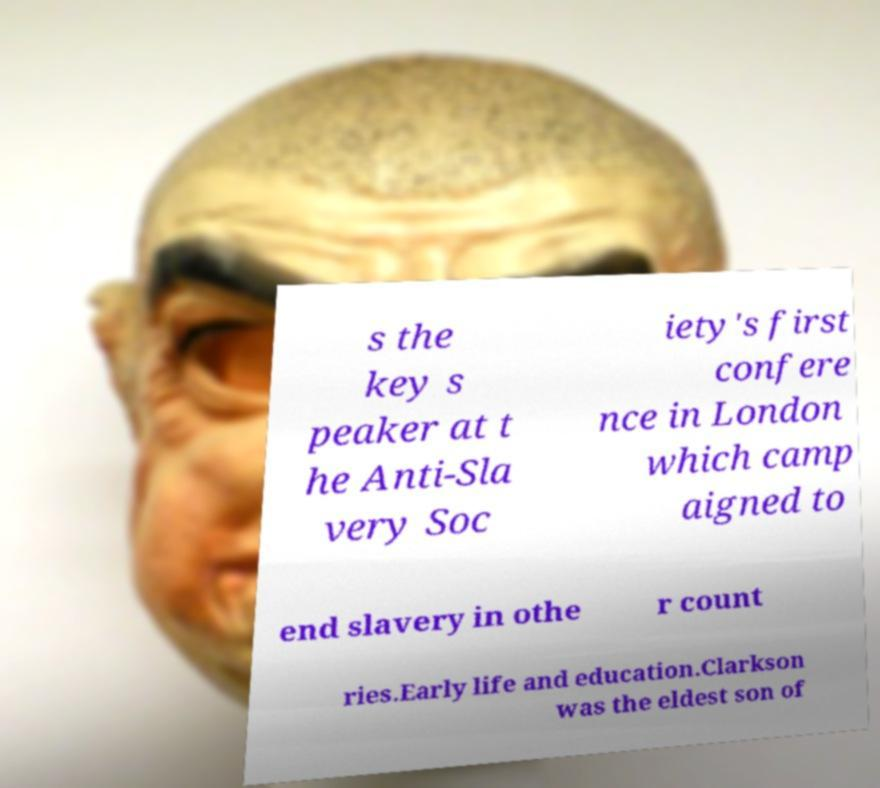What messages or text are displayed in this image? I need them in a readable, typed format. s the key s peaker at t he Anti-Sla very Soc iety's first confere nce in London which camp aigned to end slavery in othe r count ries.Early life and education.Clarkson was the eldest son of 